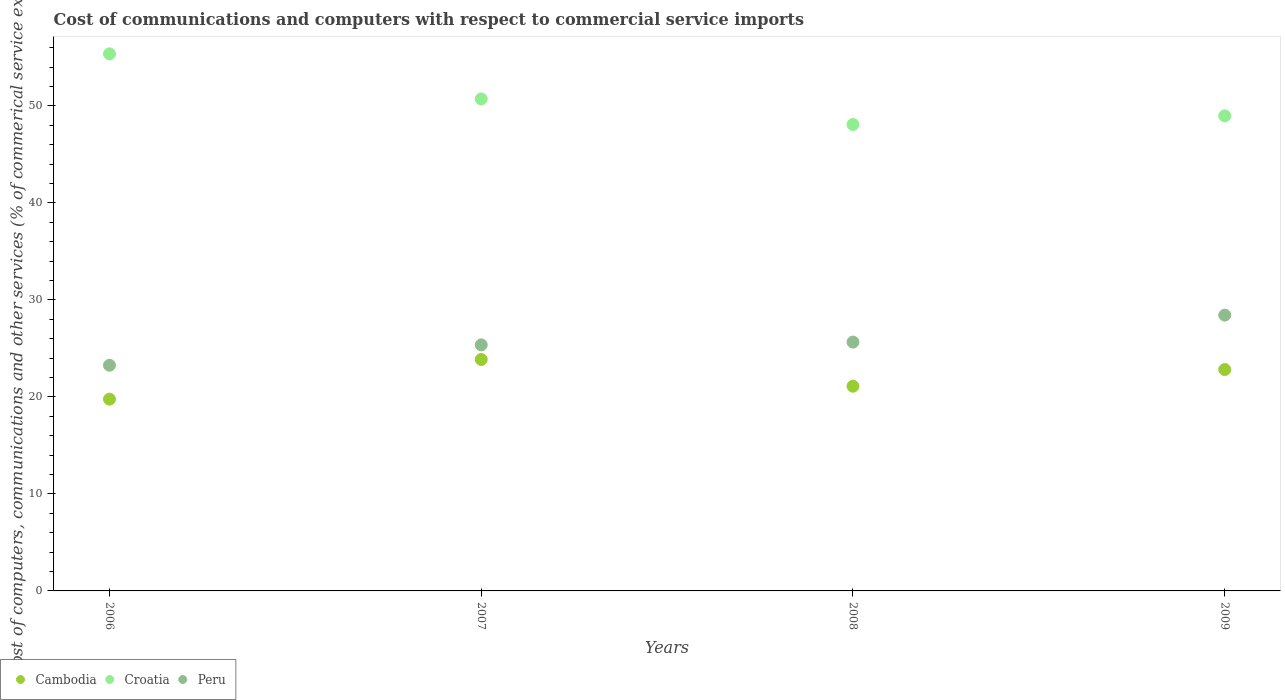Is the number of dotlines equal to the number of legend labels?
Make the answer very short. Yes. What is the cost of communications and computers in Croatia in 2006?
Your response must be concise. 55.37. Across all years, what is the maximum cost of communications and computers in Croatia?
Your response must be concise. 55.37. Across all years, what is the minimum cost of communications and computers in Croatia?
Provide a succinct answer. 48.08. In which year was the cost of communications and computers in Cambodia minimum?
Provide a succinct answer. 2006. What is the total cost of communications and computers in Peru in the graph?
Your answer should be very brief. 102.71. What is the difference between the cost of communications and computers in Peru in 2007 and that in 2008?
Provide a succinct answer. -0.29. What is the difference between the cost of communications and computers in Cambodia in 2006 and the cost of communications and computers in Croatia in 2009?
Ensure brevity in your answer.  -29.2. What is the average cost of communications and computers in Croatia per year?
Make the answer very short. 50.78. In the year 2009, what is the difference between the cost of communications and computers in Croatia and cost of communications and computers in Peru?
Offer a terse response. 20.54. In how many years, is the cost of communications and computers in Croatia greater than 26 %?
Give a very brief answer. 4. What is the ratio of the cost of communications and computers in Peru in 2006 to that in 2007?
Make the answer very short. 0.92. What is the difference between the highest and the second highest cost of communications and computers in Croatia?
Your answer should be compact. 4.65. What is the difference between the highest and the lowest cost of communications and computers in Cambodia?
Make the answer very short. 4.09. In how many years, is the cost of communications and computers in Peru greater than the average cost of communications and computers in Peru taken over all years?
Give a very brief answer. 1. Does the cost of communications and computers in Cambodia monotonically increase over the years?
Offer a very short reply. No. Is the cost of communications and computers in Peru strictly greater than the cost of communications and computers in Cambodia over the years?
Your answer should be very brief. Yes. Is the cost of communications and computers in Croatia strictly less than the cost of communications and computers in Peru over the years?
Your answer should be compact. No. How many dotlines are there?
Your answer should be compact. 3. Are the values on the major ticks of Y-axis written in scientific E-notation?
Offer a terse response. No. Where does the legend appear in the graph?
Give a very brief answer. Bottom left. How many legend labels are there?
Keep it short and to the point. 3. How are the legend labels stacked?
Ensure brevity in your answer.  Horizontal. What is the title of the graph?
Give a very brief answer. Cost of communications and computers with respect to commercial service imports. Does "Armenia" appear as one of the legend labels in the graph?
Make the answer very short. No. What is the label or title of the X-axis?
Your answer should be compact. Years. What is the label or title of the Y-axis?
Provide a short and direct response. Cost of computers, communications and other services (% of commerical service exports). What is the Cost of computers, communications and other services (% of commerical service exports) of Cambodia in 2006?
Keep it short and to the point. 19.77. What is the Cost of computers, communications and other services (% of commerical service exports) in Croatia in 2006?
Give a very brief answer. 55.37. What is the Cost of computers, communications and other services (% of commerical service exports) in Peru in 2006?
Offer a terse response. 23.26. What is the Cost of computers, communications and other services (% of commerical service exports) in Cambodia in 2007?
Keep it short and to the point. 23.86. What is the Cost of computers, communications and other services (% of commerical service exports) in Croatia in 2007?
Your response must be concise. 50.72. What is the Cost of computers, communications and other services (% of commerical service exports) in Peru in 2007?
Provide a short and direct response. 25.36. What is the Cost of computers, communications and other services (% of commerical service exports) in Cambodia in 2008?
Your answer should be compact. 21.1. What is the Cost of computers, communications and other services (% of commerical service exports) of Croatia in 2008?
Keep it short and to the point. 48.08. What is the Cost of computers, communications and other services (% of commerical service exports) of Peru in 2008?
Give a very brief answer. 25.65. What is the Cost of computers, communications and other services (% of commerical service exports) of Cambodia in 2009?
Provide a succinct answer. 22.82. What is the Cost of computers, communications and other services (% of commerical service exports) in Croatia in 2009?
Your response must be concise. 48.97. What is the Cost of computers, communications and other services (% of commerical service exports) of Peru in 2009?
Provide a short and direct response. 28.43. Across all years, what is the maximum Cost of computers, communications and other services (% of commerical service exports) of Cambodia?
Make the answer very short. 23.86. Across all years, what is the maximum Cost of computers, communications and other services (% of commerical service exports) of Croatia?
Provide a succinct answer. 55.37. Across all years, what is the maximum Cost of computers, communications and other services (% of commerical service exports) in Peru?
Your answer should be compact. 28.43. Across all years, what is the minimum Cost of computers, communications and other services (% of commerical service exports) of Cambodia?
Ensure brevity in your answer.  19.77. Across all years, what is the minimum Cost of computers, communications and other services (% of commerical service exports) of Croatia?
Make the answer very short. 48.08. Across all years, what is the minimum Cost of computers, communications and other services (% of commerical service exports) of Peru?
Your answer should be compact. 23.26. What is the total Cost of computers, communications and other services (% of commerical service exports) in Cambodia in the graph?
Offer a terse response. 87.55. What is the total Cost of computers, communications and other services (% of commerical service exports) of Croatia in the graph?
Provide a succinct answer. 203.13. What is the total Cost of computers, communications and other services (% of commerical service exports) in Peru in the graph?
Provide a short and direct response. 102.71. What is the difference between the Cost of computers, communications and other services (% of commerical service exports) of Cambodia in 2006 and that in 2007?
Your answer should be very brief. -4.09. What is the difference between the Cost of computers, communications and other services (% of commerical service exports) in Croatia in 2006 and that in 2007?
Keep it short and to the point. 4.65. What is the difference between the Cost of computers, communications and other services (% of commerical service exports) of Peru in 2006 and that in 2007?
Your response must be concise. -2.1. What is the difference between the Cost of computers, communications and other services (% of commerical service exports) of Cambodia in 2006 and that in 2008?
Offer a terse response. -1.33. What is the difference between the Cost of computers, communications and other services (% of commerical service exports) of Croatia in 2006 and that in 2008?
Keep it short and to the point. 7.29. What is the difference between the Cost of computers, communications and other services (% of commerical service exports) of Peru in 2006 and that in 2008?
Your answer should be very brief. -2.39. What is the difference between the Cost of computers, communications and other services (% of commerical service exports) in Cambodia in 2006 and that in 2009?
Your answer should be very brief. -3.05. What is the difference between the Cost of computers, communications and other services (% of commerical service exports) of Croatia in 2006 and that in 2009?
Keep it short and to the point. 6.39. What is the difference between the Cost of computers, communications and other services (% of commerical service exports) in Peru in 2006 and that in 2009?
Give a very brief answer. -5.17. What is the difference between the Cost of computers, communications and other services (% of commerical service exports) in Cambodia in 2007 and that in 2008?
Your answer should be compact. 2.76. What is the difference between the Cost of computers, communications and other services (% of commerical service exports) of Croatia in 2007 and that in 2008?
Make the answer very short. 2.64. What is the difference between the Cost of computers, communications and other services (% of commerical service exports) of Peru in 2007 and that in 2008?
Ensure brevity in your answer.  -0.29. What is the difference between the Cost of computers, communications and other services (% of commerical service exports) of Cambodia in 2007 and that in 2009?
Provide a short and direct response. 1.04. What is the difference between the Cost of computers, communications and other services (% of commerical service exports) in Croatia in 2007 and that in 2009?
Give a very brief answer. 1.75. What is the difference between the Cost of computers, communications and other services (% of commerical service exports) of Peru in 2007 and that in 2009?
Make the answer very short. -3.07. What is the difference between the Cost of computers, communications and other services (% of commerical service exports) of Cambodia in 2008 and that in 2009?
Ensure brevity in your answer.  -1.72. What is the difference between the Cost of computers, communications and other services (% of commerical service exports) of Croatia in 2008 and that in 2009?
Offer a very short reply. -0.89. What is the difference between the Cost of computers, communications and other services (% of commerical service exports) in Peru in 2008 and that in 2009?
Keep it short and to the point. -2.78. What is the difference between the Cost of computers, communications and other services (% of commerical service exports) of Cambodia in 2006 and the Cost of computers, communications and other services (% of commerical service exports) of Croatia in 2007?
Provide a succinct answer. -30.95. What is the difference between the Cost of computers, communications and other services (% of commerical service exports) in Cambodia in 2006 and the Cost of computers, communications and other services (% of commerical service exports) in Peru in 2007?
Your response must be concise. -5.6. What is the difference between the Cost of computers, communications and other services (% of commerical service exports) of Croatia in 2006 and the Cost of computers, communications and other services (% of commerical service exports) of Peru in 2007?
Provide a short and direct response. 30. What is the difference between the Cost of computers, communications and other services (% of commerical service exports) of Cambodia in 2006 and the Cost of computers, communications and other services (% of commerical service exports) of Croatia in 2008?
Give a very brief answer. -28.31. What is the difference between the Cost of computers, communications and other services (% of commerical service exports) of Cambodia in 2006 and the Cost of computers, communications and other services (% of commerical service exports) of Peru in 2008?
Provide a short and direct response. -5.88. What is the difference between the Cost of computers, communications and other services (% of commerical service exports) of Croatia in 2006 and the Cost of computers, communications and other services (% of commerical service exports) of Peru in 2008?
Your answer should be compact. 29.71. What is the difference between the Cost of computers, communications and other services (% of commerical service exports) in Cambodia in 2006 and the Cost of computers, communications and other services (% of commerical service exports) in Croatia in 2009?
Ensure brevity in your answer.  -29.2. What is the difference between the Cost of computers, communications and other services (% of commerical service exports) of Cambodia in 2006 and the Cost of computers, communications and other services (% of commerical service exports) of Peru in 2009?
Ensure brevity in your answer.  -8.66. What is the difference between the Cost of computers, communications and other services (% of commerical service exports) of Croatia in 2006 and the Cost of computers, communications and other services (% of commerical service exports) of Peru in 2009?
Your response must be concise. 26.94. What is the difference between the Cost of computers, communications and other services (% of commerical service exports) in Cambodia in 2007 and the Cost of computers, communications and other services (% of commerical service exports) in Croatia in 2008?
Offer a terse response. -24.22. What is the difference between the Cost of computers, communications and other services (% of commerical service exports) of Cambodia in 2007 and the Cost of computers, communications and other services (% of commerical service exports) of Peru in 2008?
Your answer should be very brief. -1.79. What is the difference between the Cost of computers, communications and other services (% of commerical service exports) of Croatia in 2007 and the Cost of computers, communications and other services (% of commerical service exports) of Peru in 2008?
Your answer should be compact. 25.07. What is the difference between the Cost of computers, communications and other services (% of commerical service exports) in Cambodia in 2007 and the Cost of computers, communications and other services (% of commerical service exports) in Croatia in 2009?
Keep it short and to the point. -25.11. What is the difference between the Cost of computers, communications and other services (% of commerical service exports) of Cambodia in 2007 and the Cost of computers, communications and other services (% of commerical service exports) of Peru in 2009?
Ensure brevity in your answer.  -4.57. What is the difference between the Cost of computers, communications and other services (% of commerical service exports) of Croatia in 2007 and the Cost of computers, communications and other services (% of commerical service exports) of Peru in 2009?
Keep it short and to the point. 22.29. What is the difference between the Cost of computers, communications and other services (% of commerical service exports) of Cambodia in 2008 and the Cost of computers, communications and other services (% of commerical service exports) of Croatia in 2009?
Make the answer very short. -27.87. What is the difference between the Cost of computers, communications and other services (% of commerical service exports) of Cambodia in 2008 and the Cost of computers, communications and other services (% of commerical service exports) of Peru in 2009?
Give a very brief answer. -7.33. What is the difference between the Cost of computers, communications and other services (% of commerical service exports) of Croatia in 2008 and the Cost of computers, communications and other services (% of commerical service exports) of Peru in 2009?
Keep it short and to the point. 19.65. What is the average Cost of computers, communications and other services (% of commerical service exports) in Cambodia per year?
Make the answer very short. 21.89. What is the average Cost of computers, communications and other services (% of commerical service exports) in Croatia per year?
Your response must be concise. 50.78. What is the average Cost of computers, communications and other services (% of commerical service exports) in Peru per year?
Ensure brevity in your answer.  25.68. In the year 2006, what is the difference between the Cost of computers, communications and other services (% of commerical service exports) in Cambodia and Cost of computers, communications and other services (% of commerical service exports) in Croatia?
Offer a very short reply. -35.6. In the year 2006, what is the difference between the Cost of computers, communications and other services (% of commerical service exports) of Cambodia and Cost of computers, communications and other services (% of commerical service exports) of Peru?
Your answer should be very brief. -3.5. In the year 2006, what is the difference between the Cost of computers, communications and other services (% of commerical service exports) in Croatia and Cost of computers, communications and other services (% of commerical service exports) in Peru?
Your answer should be very brief. 32.1. In the year 2007, what is the difference between the Cost of computers, communications and other services (% of commerical service exports) in Cambodia and Cost of computers, communications and other services (% of commerical service exports) in Croatia?
Give a very brief answer. -26.86. In the year 2007, what is the difference between the Cost of computers, communications and other services (% of commerical service exports) in Cambodia and Cost of computers, communications and other services (% of commerical service exports) in Peru?
Offer a terse response. -1.51. In the year 2007, what is the difference between the Cost of computers, communications and other services (% of commerical service exports) in Croatia and Cost of computers, communications and other services (% of commerical service exports) in Peru?
Offer a terse response. 25.35. In the year 2008, what is the difference between the Cost of computers, communications and other services (% of commerical service exports) in Cambodia and Cost of computers, communications and other services (% of commerical service exports) in Croatia?
Give a very brief answer. -26.98. In the year 2008, what is the difference between the Cost of computers, communications and other services (% of commerical service exports) in Cambodia and Cost of computers, communications and other services (% of commerical service exports) in Peru?
Your answer should be very brief. -4.55. In the year 2008, what is the difference between the Cost of computers, communications and other services (% of commerical service exports) of Croatia and Cost of computers, communications and other services (% of commerical service exports) of Peru?
Your response must be concise. 22.43. In the year 2009, what is the difference between the Cost of computers, communications and other services (% of commerical service exports) of Cambodia and Cost of computers, communications and other services (% of commerical service exports) of Croatia?
Provide a short and direct response. -26.15. In the year 2009, what is the difference between the Cost of computers, communications and other services (% of commerical service exports) in Cambodia and Cost of computers, communications and other services (% of commerical service exports) in Peru?
Provide a succinct answer. -5.61. In the year 2009, what is the difference between the Cost of computers, communications and other services (% of commerical service exports) of Croatia and Cost of computers, communications and other services (% of commerical service exports) of Peru?
Provide a succinct answer. 20.54. What is the ratio of the Cost of computers, communications and other services (% of commerical service exports) in Cambodia in 2006 to that in 2007?
Give a very brief answer. 0.83. What is the ratio of the Cost of computers, communications and other services (% of commerical service exports) in Croatia in 2006 to that in 2007?
Provide a succinct answer. 1.09. What is the ratio of the Cost of computers, communications and other services (% of commerical service exports) of Peru in 2006 to that in 2007?
Provide a succinct answer. 0.92. What is the ratio of the Cost of computers, communications and other services (% of commerical service exports) of Cambodia in 2006 to that in 2008?
Provide a succinct answer. 0.94. What is the ratio of the Cost of computers, communications and other services (% of commerical service exports) in Croatia in 2006 to that in 2008?
Keep it short and to the point. 1.15. What is the ratio of the Cost of computers, communications and other services (% of commerical service exports) in Peru in 2006 to that in 2008?
Offer a very short reply. 0.91. What is the ratio of the Cost of computers, communications and other services (% of commerical service exports) in Cambodia in 2006 to that in 2009?
Your answer should be compact. 0.87. What is the ratio of the Cost of computers, communications and other services (% of commerical service exports) in Croatia in 2006 to that in 2009?
Provide a short and direct response. 1.13. What is the ratio of the Cost of computers, communications and other services (% of commerical service exports) in Peru in 2006 to that in 2009?
Keep it short and to the point. 0.82. What is the ratio of the Cost of computers, communications and other services (% of commerical service exports) of Cambodia in 2007 to that in 2008?
Give a very brief answer. 1.13. What is the ratio of the Cost of computers, communications and other services (% of commerical service exports) in Croatia in 2007 to that in 2008?
Your answer should be very brief. 1.05. What is the ratio of the Cost of computers, communications and other services (% of commerical service exports) in Peru in 2007 to that in 2008?
Offer a terse response. 0.99. What is the ratio of the Cost of computers, communications and other services (% of commerical service exports) of Cambodia in 2007 to that in 2009?
Give a very brief answer. 1.05. What is the ratio of the Cost of computers, communications and other services (% of commerical service exports) of Croatia in 2007 to that in 2009?
Make the answer very short. 1.04. What is the ratio of the Cost of computers, communications and other services (% of commerical service exports) of Peru in 2007 to that in 2009?
Your answer should be very brief. 0.89. What is the ratio of the Cost of computers, communications and other services (% of commerical service exports) of Cambodia in 2008 to that in 2009?
Provide a succinct answer. 0.92. What is the ratio of the Cost of computers, communications and other services (% of commerical service exports) of Croatia in 2008 to that in 2009?
Your answer should be very brief. 0.98. What is the ratio of the Cost of computers, communications and other services (% of commerical service exports) in Peru in 2008 to that in 2009?
Provide a short and direct response. 0.9. What is the difference between the highest and the second highest Cost of computers, communications and other services (% of commerical service exports) in Cambodia?
Ensure brevity in your answer.  1.04. What is the difference between the highest and the second highest Cost of computers, communications and other services (% of commerical service exports) of Croatia?
Offer a terse response. 4.65. What is the difference between the highest and the second highest Cost of computers, communications and other services (% of commerical service exports) in Peru?
Keep it short and to the point. 2.78. What is the difference between the highest and the lowest Cost of computers, communications and other services (% of commerical service exports) of Cambodia?
Give a very brief answer. 4.09. What is the difference between the highest and the lowest Cost of computers, communications and other services (% of commerical service exports) of Croatia?
Provide a short and direct response. 7.29. What is the difference between the highest and the lowest Cost of computers, communications and other services (% of commerical service exports) of Peru?
Your answer should be compact. 5.17. 